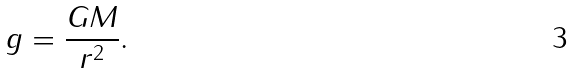<formula> <loc_0><loc_0><loc_500><loc_500>g = \frac { G M } { r ^ { 2 } } .</formula> 